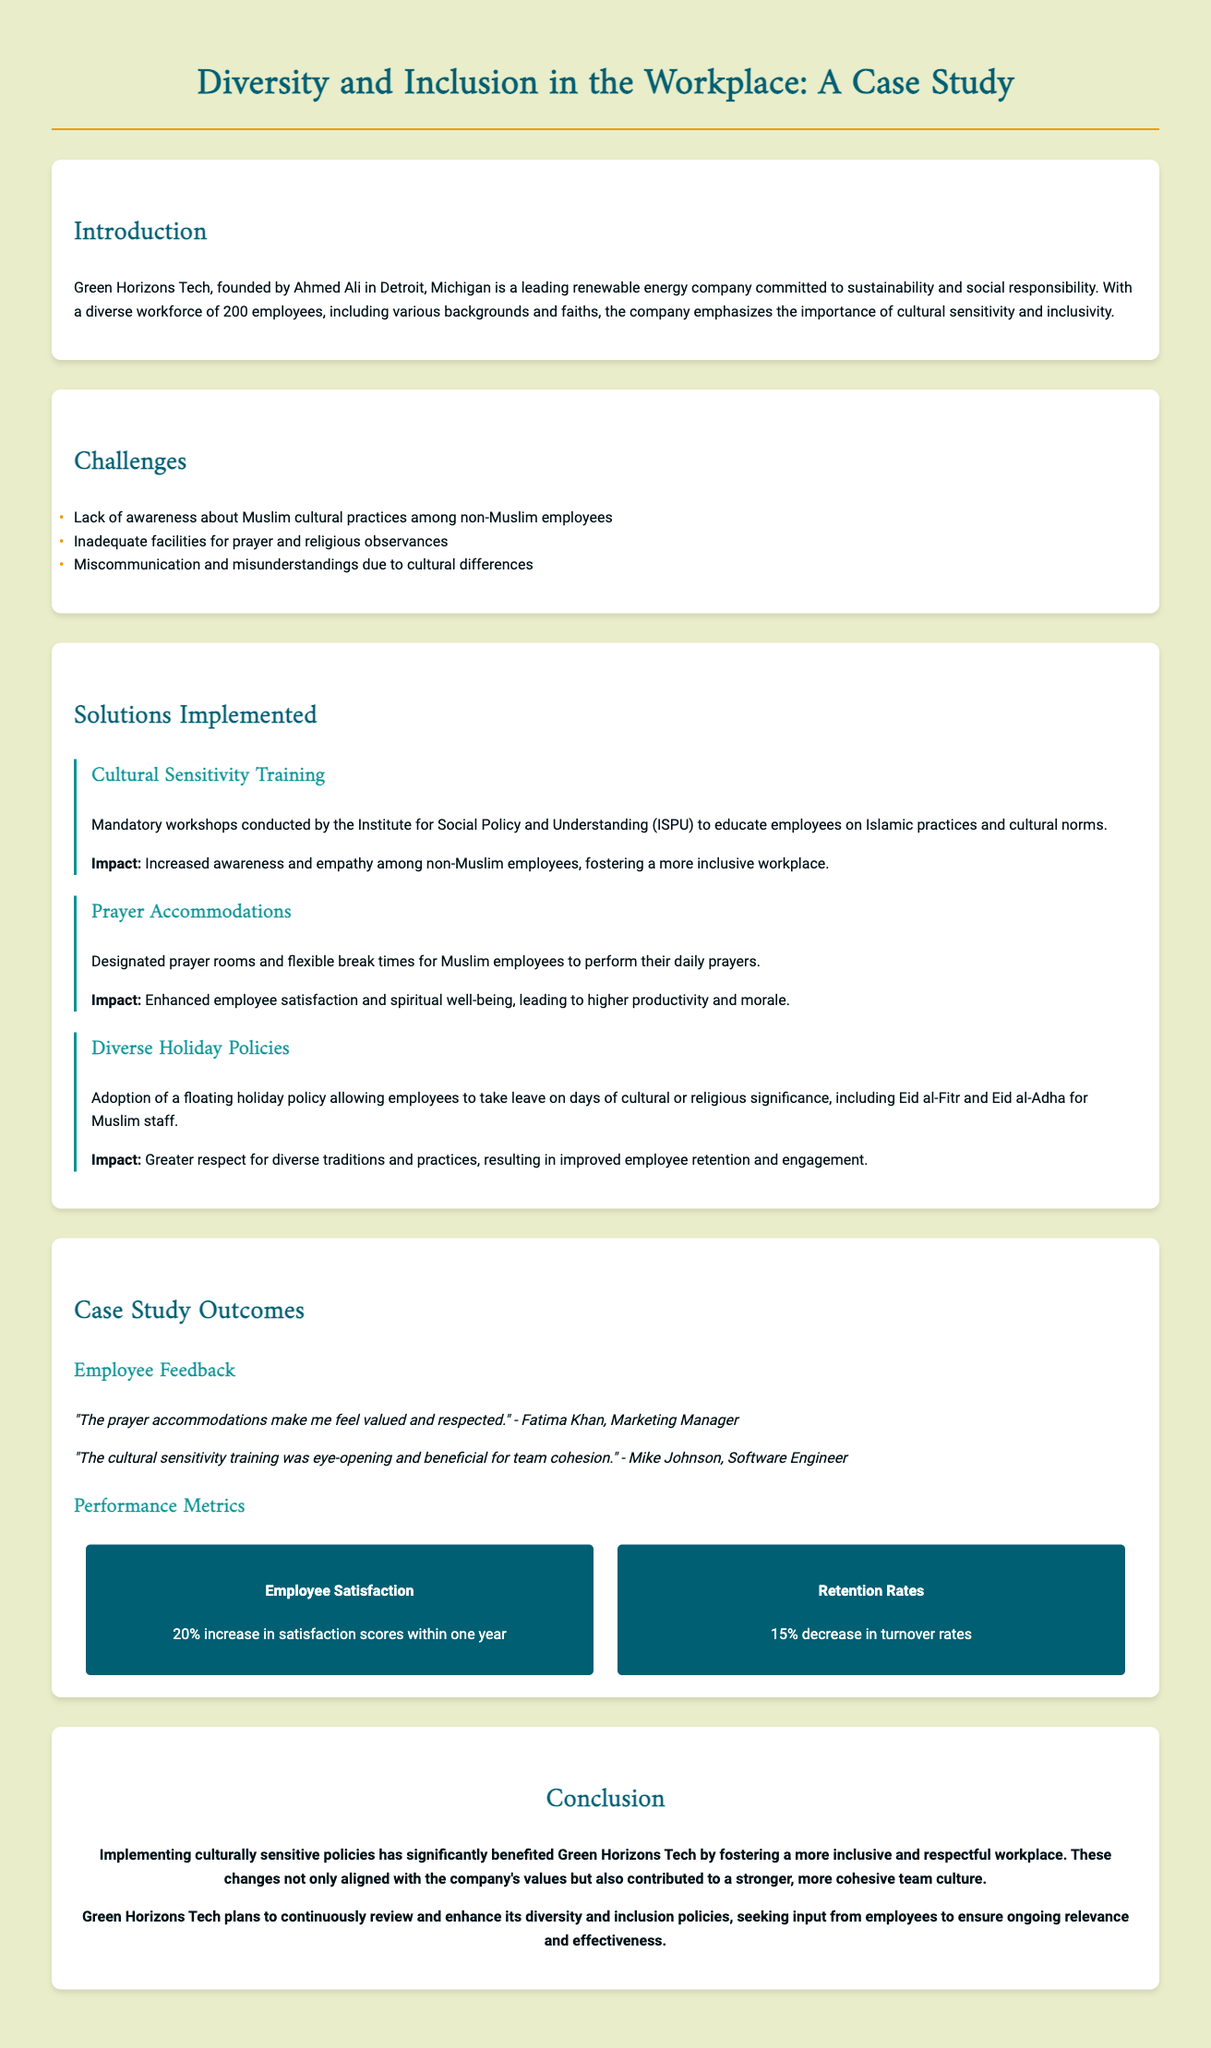What is the name of the company in the case study? The name of the company is Green Horizons Tech, which is highlighted in the introduction.
Answer: Green Horizons Tech Who founded Green Horizons Tech? The document states that Ahmed Ali is the founder of the company.
Answer: Ahmed Ali How many employees does Green Horizons Tech have? The introduction specifies that the company has a diverse workforce of 200 employees.
Answer: 200 What training was implemented to increase awareness among employees? The case study mentions mandatory workshops conducted by the Institute for Social Policy and Understanding (ISPU) for cultural sensitivity training.
Answer: Cultural Sensitivity Training What facilities were designated for Muslim employees? The document highlights that prayer accommodations were made, including designated prayer rooms.
Answer: Designated prayer rooms What percentage increase in employee satisfaction was reported? According to the performance metrics section, there was a 20% increase in satisfaction scores within one year.
Answer: 20% What is the floating holiday policy? The document states that the policy allows employees to take leave on days of cultural or religious significance.
Answer: Leave on cultural or religious significance What feedback did Fatima Khan give regarding the implementation? Fatima Khan expressed that the prayer accommodations made her feel valued and respected.
Answer: Valued and respected What is the predicted plan for Green Horizons Tech regarding its policies? The conclusion indicates that Green Horizons Tech plans to continuously review and enhance its diversity and inclusion policies.
Answer: Continuously review and enhance 